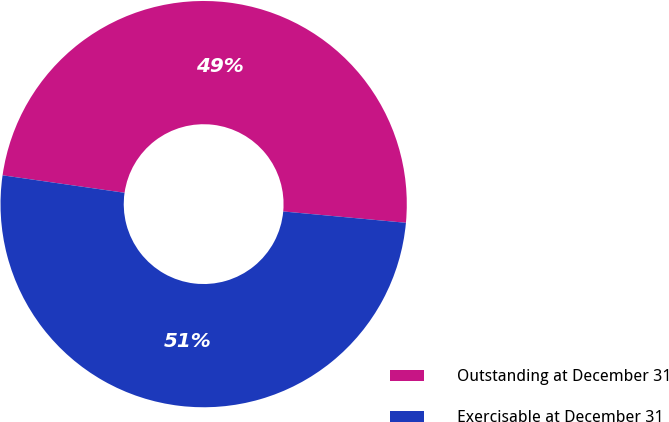Convert chart to OTSL. <chart><loc_0><loc_0><loc_500><loc_500><pie_chart><fcel>Outstanding at December 31<fcel>Exercisable at December 31<nl><fcel>49.2%<fcel>50.8%<nl></chart> 